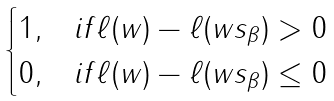<formula> <loc_0><loc_0><loc_500><loc_500>\begin{cases} 1 , & i f \ell ( w ) - \ell ( w s _ { \beta } ) > 0 \\ 0 , & i f \ell ( w ) - \ell ( w s _ { \beta } ) \leq 0 \end{cases}</formula> 